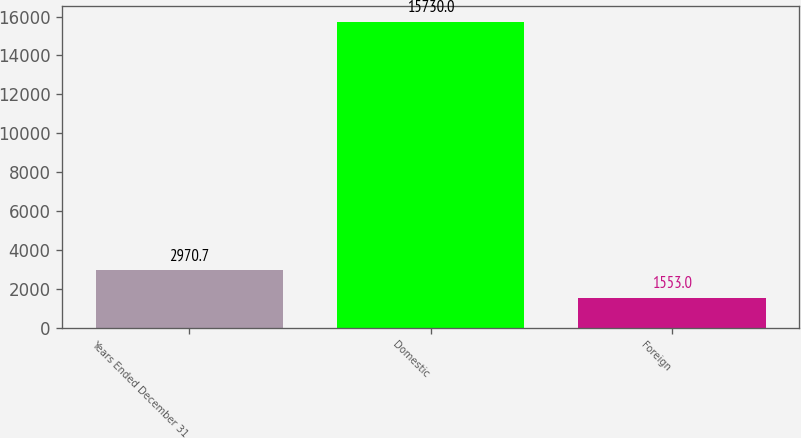Convert chart to OTSL. <chart><loc_0><loc_0><loc_500><loc_500><bar_chart><fcel>Years Ended December 31<fcel>Domestic<fcel>Foreign<nl><fcel>2970.7<fcel>15730<fcel>1553<nl></chart> 